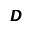<formula> <loc_0><loc_0><loc_500><loc_500>\pm b { D }</formula> 